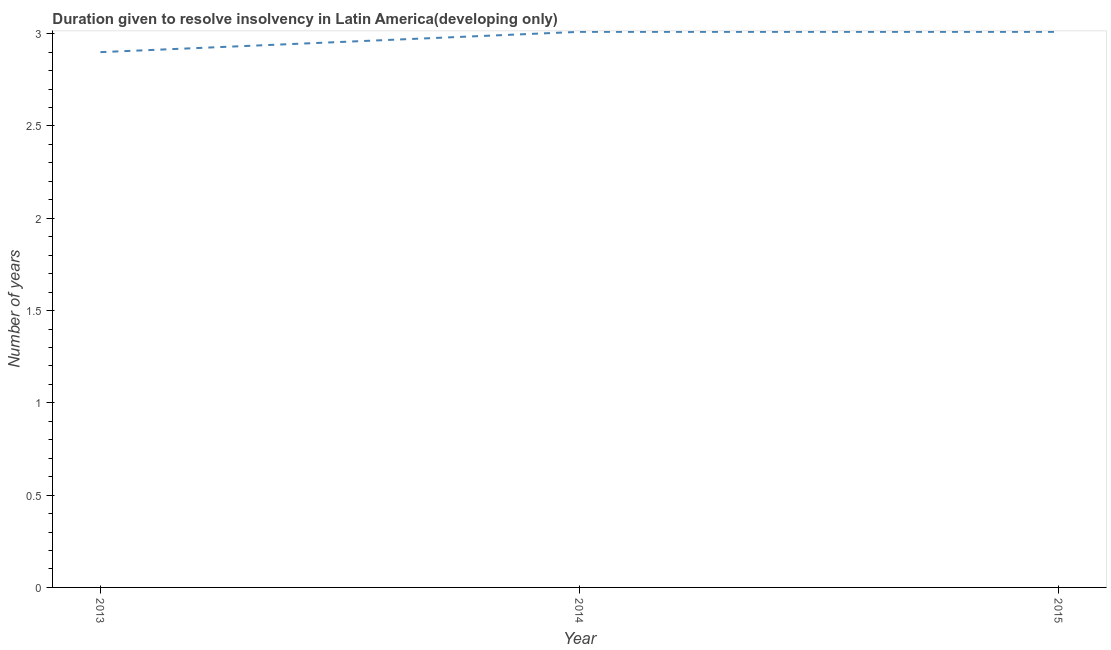What is the number of years to resolve insolvency in 2014?
Ensure brevity in your answer.  3.01. Across all years, what is the maximum number of years to resolve insolvency?
Your answer should be very brief. 3.01. In which year was the number of years to resolve insolvency minimum?
Offer a very short reply. 2013. What is the sum of the number of years to resolve insolvency?
Give a very brief answer. 8.92. What is the average number of years to resolve insolvency per year?
Offer a terse response. 2.97. What is the median number of years to resolve insolvency?
Ensure brevity in your answer.  3.01. Do a majority of the years between 2013 and 2014 (inclusive) have number of years to resolve insolvency greater than 0.5 ?
Provide a short and direct response. Yes. Is the sum of the number of years to resolve insolvency in 2013 and 2015 greater than the maximum number of years to resolve insolvency across all years?
Your response must be concise. Yes. What is the difference between the highest and the lowest number of years to resolve insolvency?
Your answer should be very brief. 0.11. How many lines are there?
Provide a succinct answer. 1. What is the difference between two consecutive major ticks on the Y-axis?
Your answer should be compact. 0.5. Are the values on the major ticks of Y-axis written in scientific E-notation?
Your answer should be compact. No. Does the graph contain any zero values?
Your response must be concise. No. Does the graph contain grids?
Keep it short and to the point. No. What is the title of the graph?
Provide a short and direct response. Duration given to resolve insolvency in Latin America(developing only). What is the label or title of the X-axis?
Make the answer very short. Year. What is the label or title of the Y-axis?
Your response must be concise. Number of years. What is the Number of years in 2014?
Offer a very short reply. 3.01. What is the Number of years in 2015?
Provide a succinct answer. 3.01. What is the difference between the Number of years in 2013 and 2014?
Ensure brevity in your answer.  -0.11. What is the difference between the Number of years in 2013 and 2015?
Offer a terse response. -0.11. What is the difference between the Number of years in 2014 and 2015?
Make the answer very short. 0. 